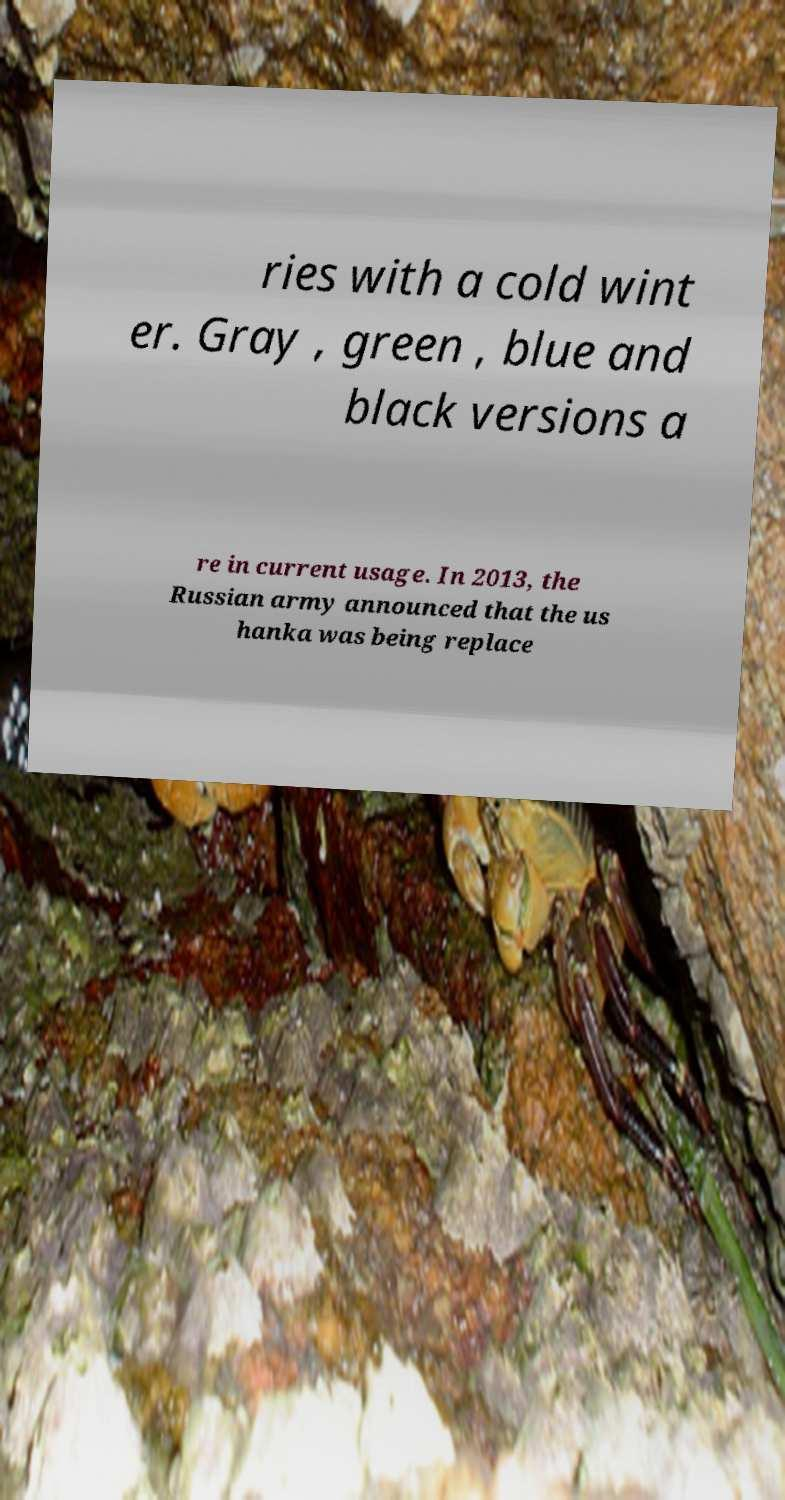Could you assist in decoding the text presented in this image and type it out clearly? ries with a cold wint er. Gray , green , blue and black versions a re in current usage. In 2013, the Russian army announced that the us hanka was being replace 